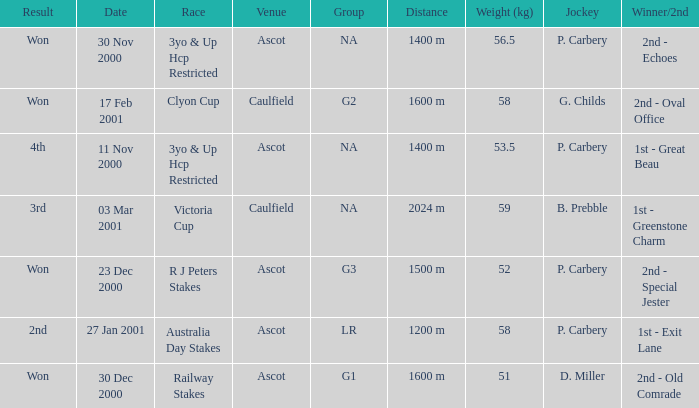What group info is available for the 56.5 kg weight? NA. 